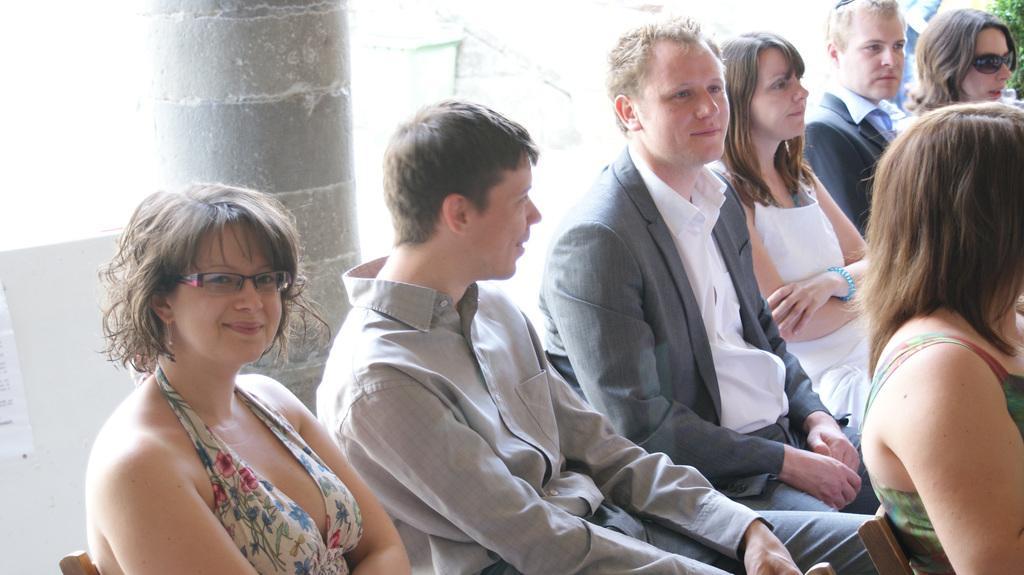In one or two sentences, can you explain what this image depicts? This picture seems to be clicked outside. On the right we can see the group of women sitting on the chairs and we can see a person wearing shirt and sitting on the chair and we can see the two persons wearing blazers and sitting. In the background we can see the pillar, green leaves and some other objects. 